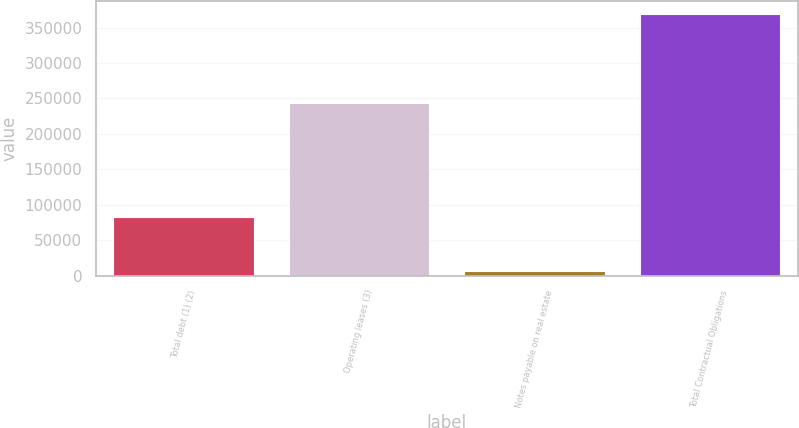Convert chart. <chart><loc_0><loc_0><loc_500><loc_500><bar_chart><fcel>Total debt (1) (2)<fcel>Operating leases (3)<fcel>Notes payable on real estate<fcel>Total Contractual Obligations<nl><fcel>82425<fcel>243327<fcel>7027<fcel>368785<nl></chart> 